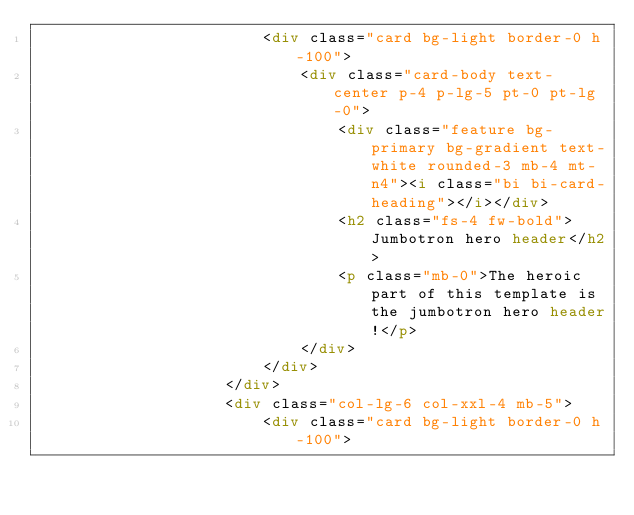<code> <loc_0><loc_0><loc_500><loc_500><_HTML_>                        <div class="card bg-light border-0 h-100">
                            <div class="card-body text-center p-4 p-lg-5 pt-0 pt-lg-0">
                                <div class="feature bg-primary bg-gradient text-white rounded-3 mb-4 mt-n4"><i class="bi bi-card-heading"></i></div>
                                <h2 class="fs-4 fw-bold">Jumbotron hero header</h2>
                                <p class="mb-0">The heroic part of this template is the jumbotron hero header!</p>
                            </div>
                        </div>
                    </div>
                    <div class="col-lg-6 col-xxl-4 mb-5">
                        <div class="card bg-light border-0 h-100"></code> 